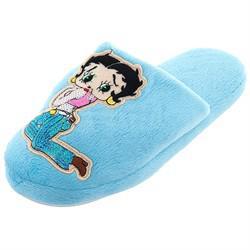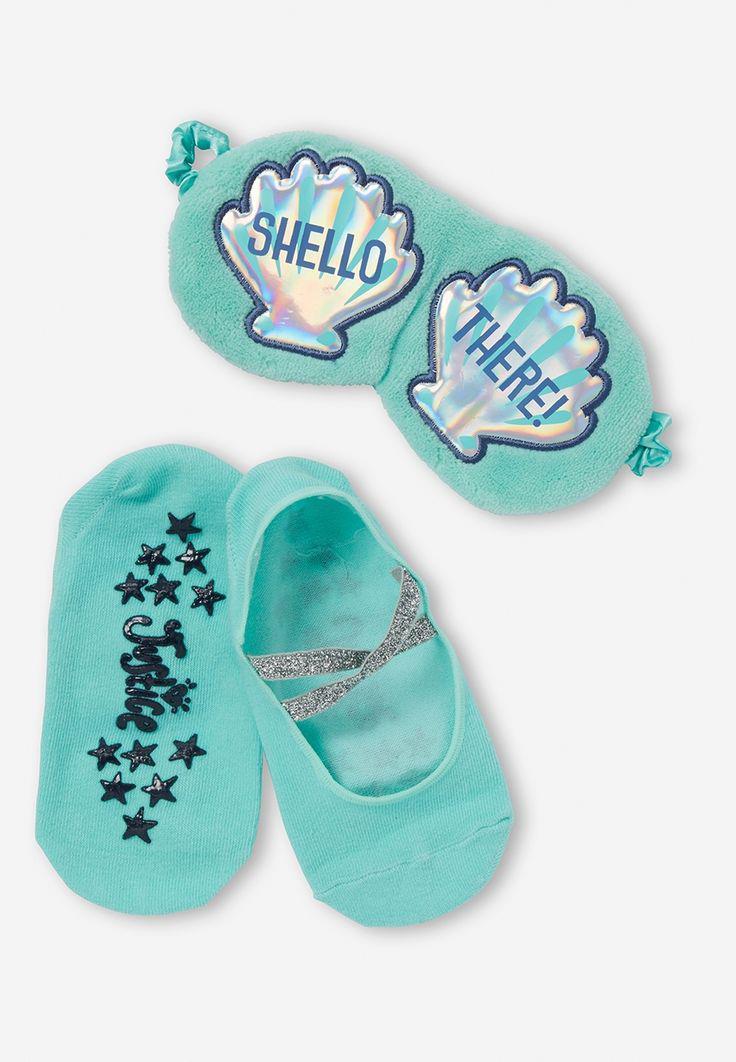The first image is the image on the left, the second image is the image on the right. Analyze the images presented: Is the assertion "there is a pair of slippers with on on its side, with eyes on the front" valid? Answer yes or no. No. 